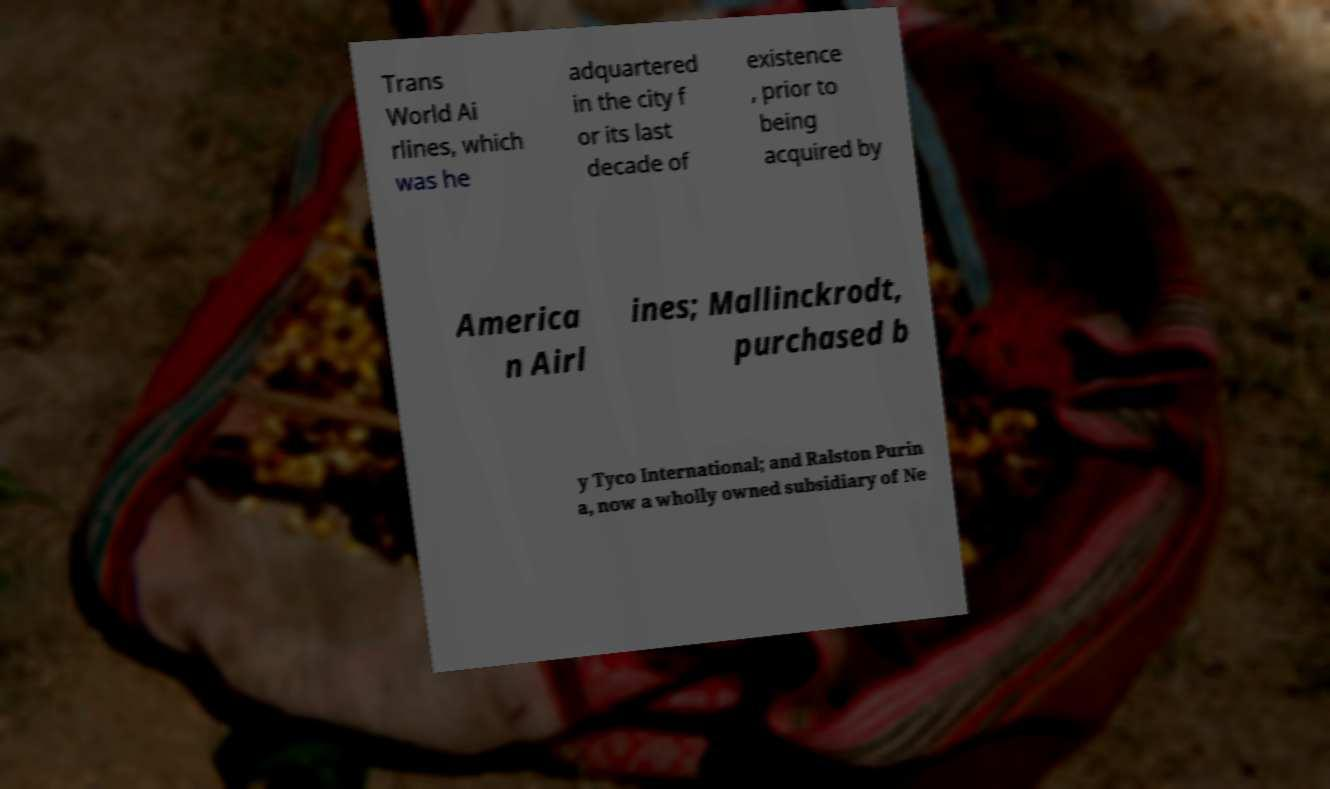What messages or text are displayed in this image? I need them in a readable, typed format. Trans World Ai rlines, which was he adquartered in the city f or its last decade of existence , prior to being acquired by America n Airl ines; Mallinckrodt, purchased b y Tyco International; and Ralston Purin a, now a wholly owned subsidiary of Ne 